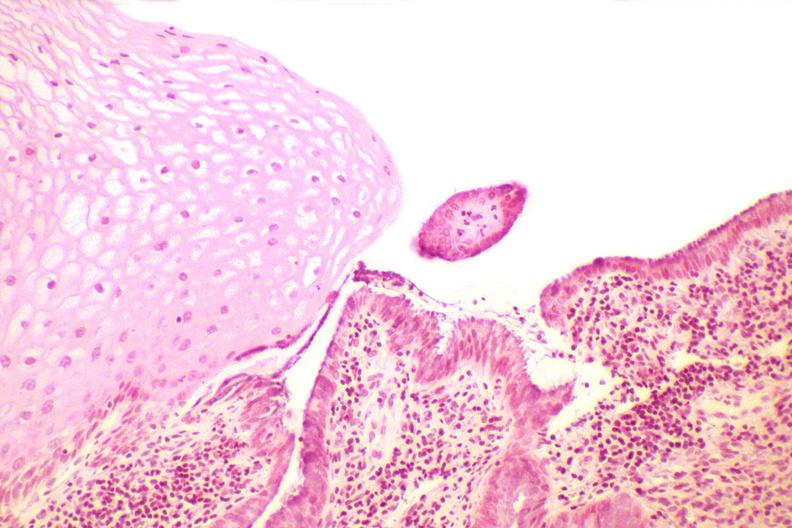what does this image show?
Answer the question using a single word or phrase. Cervix 